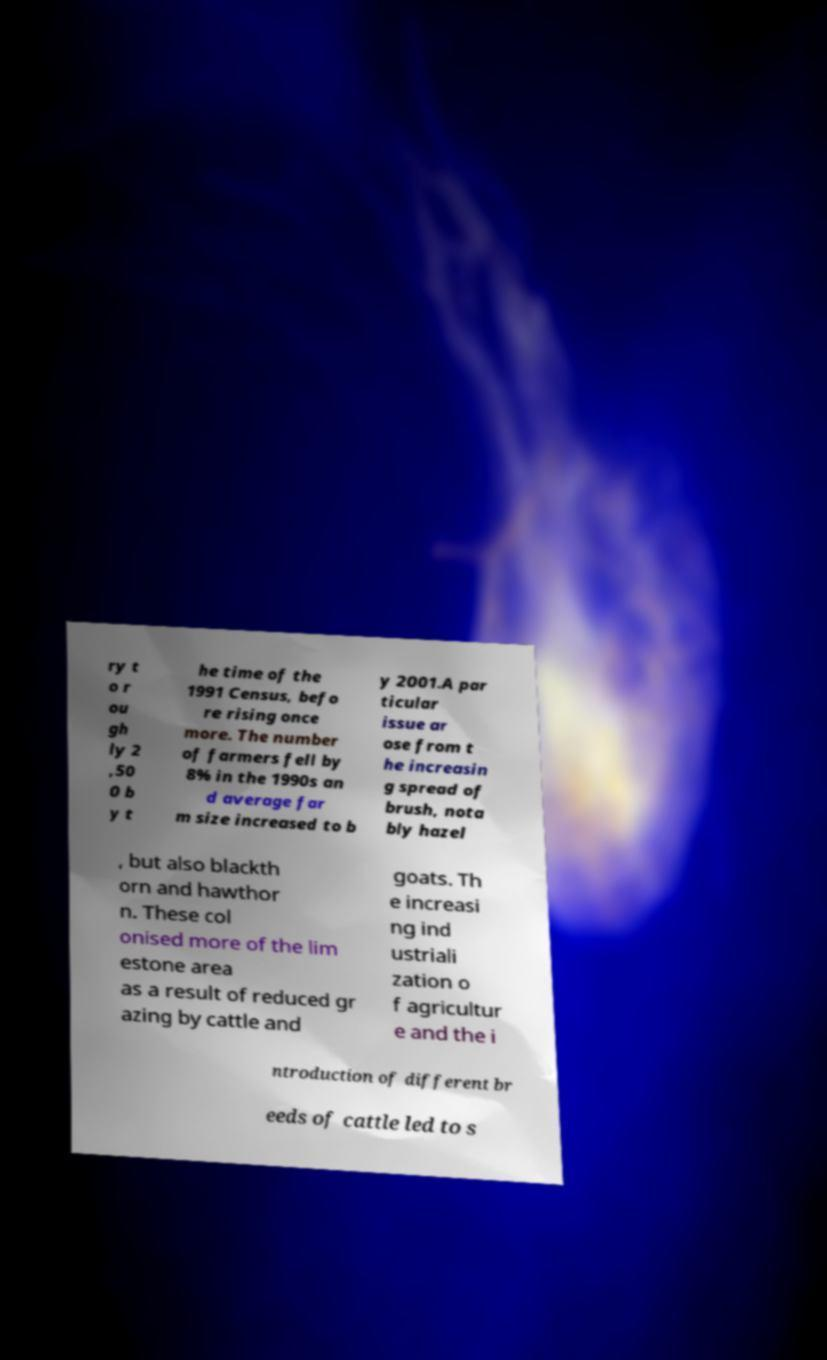Could you extract and type out the text from this image? ry t o r ou gh ly 2 ,50 0 b y t he time of the 1991 Census, befo re rising once more. The number of farmers fell by 8% in the 1990s an d average far m size increased to b y 2001.A par ticular issue ar ose from t he increasin g spread of brush, nota bly hazel , but also blackth orn and hawthor n. These col onised more of the lim estone area as a result of reduced gr azing by cattle and goats. Th e increasi ng ind ustriali zation o f agricultur e and the i ntroduction of different br eeds of cattle led to s 